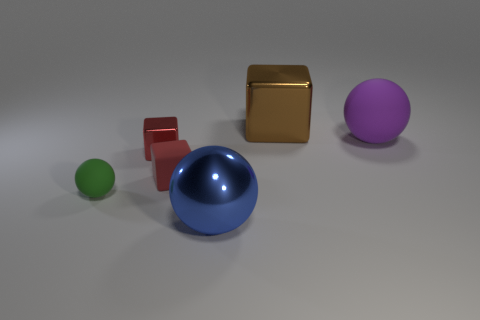Subtract all brown cubes. How many cubes are left? 2 Add 4 tiny brown shiny objects. How many objects exist? 10 Subtract all yellow spheres. How many red blocks are left? 2 Subtract all blue balls. How many balls are left? 2 Add 2 big purple things. How many big purple things exist? 3 Subtract 0 brown cylinders. How many objects are left? 6 Subtract all red balls. Subtract all brown cylinders. How many balls are left? 3 Subtract all large matte things. Subtract all tiny green rubber objects. How many objects are left? 4 Add 6 blue things. How many blue things are left? 7 